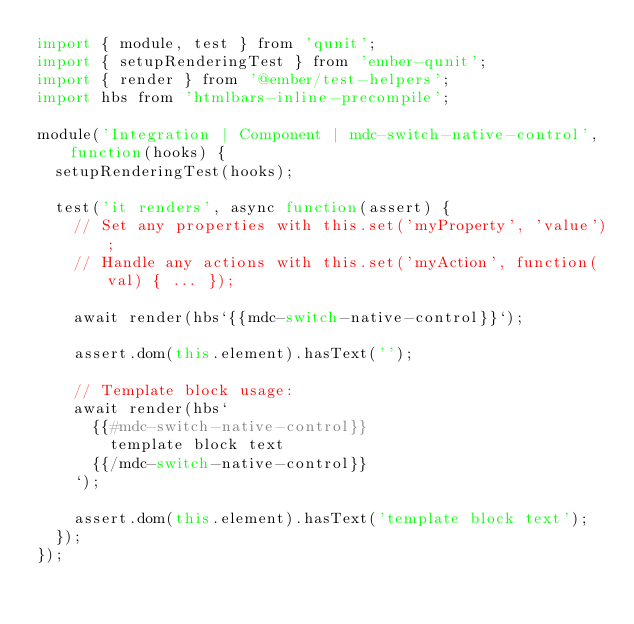<code> <loc_0><loc_0><loc_500><loc_500><_JavaScript_>import { module, test } from 'qunit';
import { setupRenderingTest } from 'ember-qunit';
import { render } from '@ember/test-helpers';
import hbs from 'htmlbars-inline-precompile';

module('Integration | Component | mdc-switch-native-control', function(hooks) {
  setupRenderingTest(hooks);

  test('it renders', async function(assert) {
    // Set any properties with this.set('myProperty', 'value');
    // Handle any actions with this.set('myAction', function(val) { ... });

    await render(hbs`{{mdc-switch-native-control}}`);

    assert.dom(this.element).hasText('');

    // Template block usage:
    await render(hbs`
      {{#mdc-switch-native-control}}
        template block text
      {{/mdc-switch-native-control}}
    `);

    assert.dom(this.element).hasText('template block text');
  });
});
</code> 